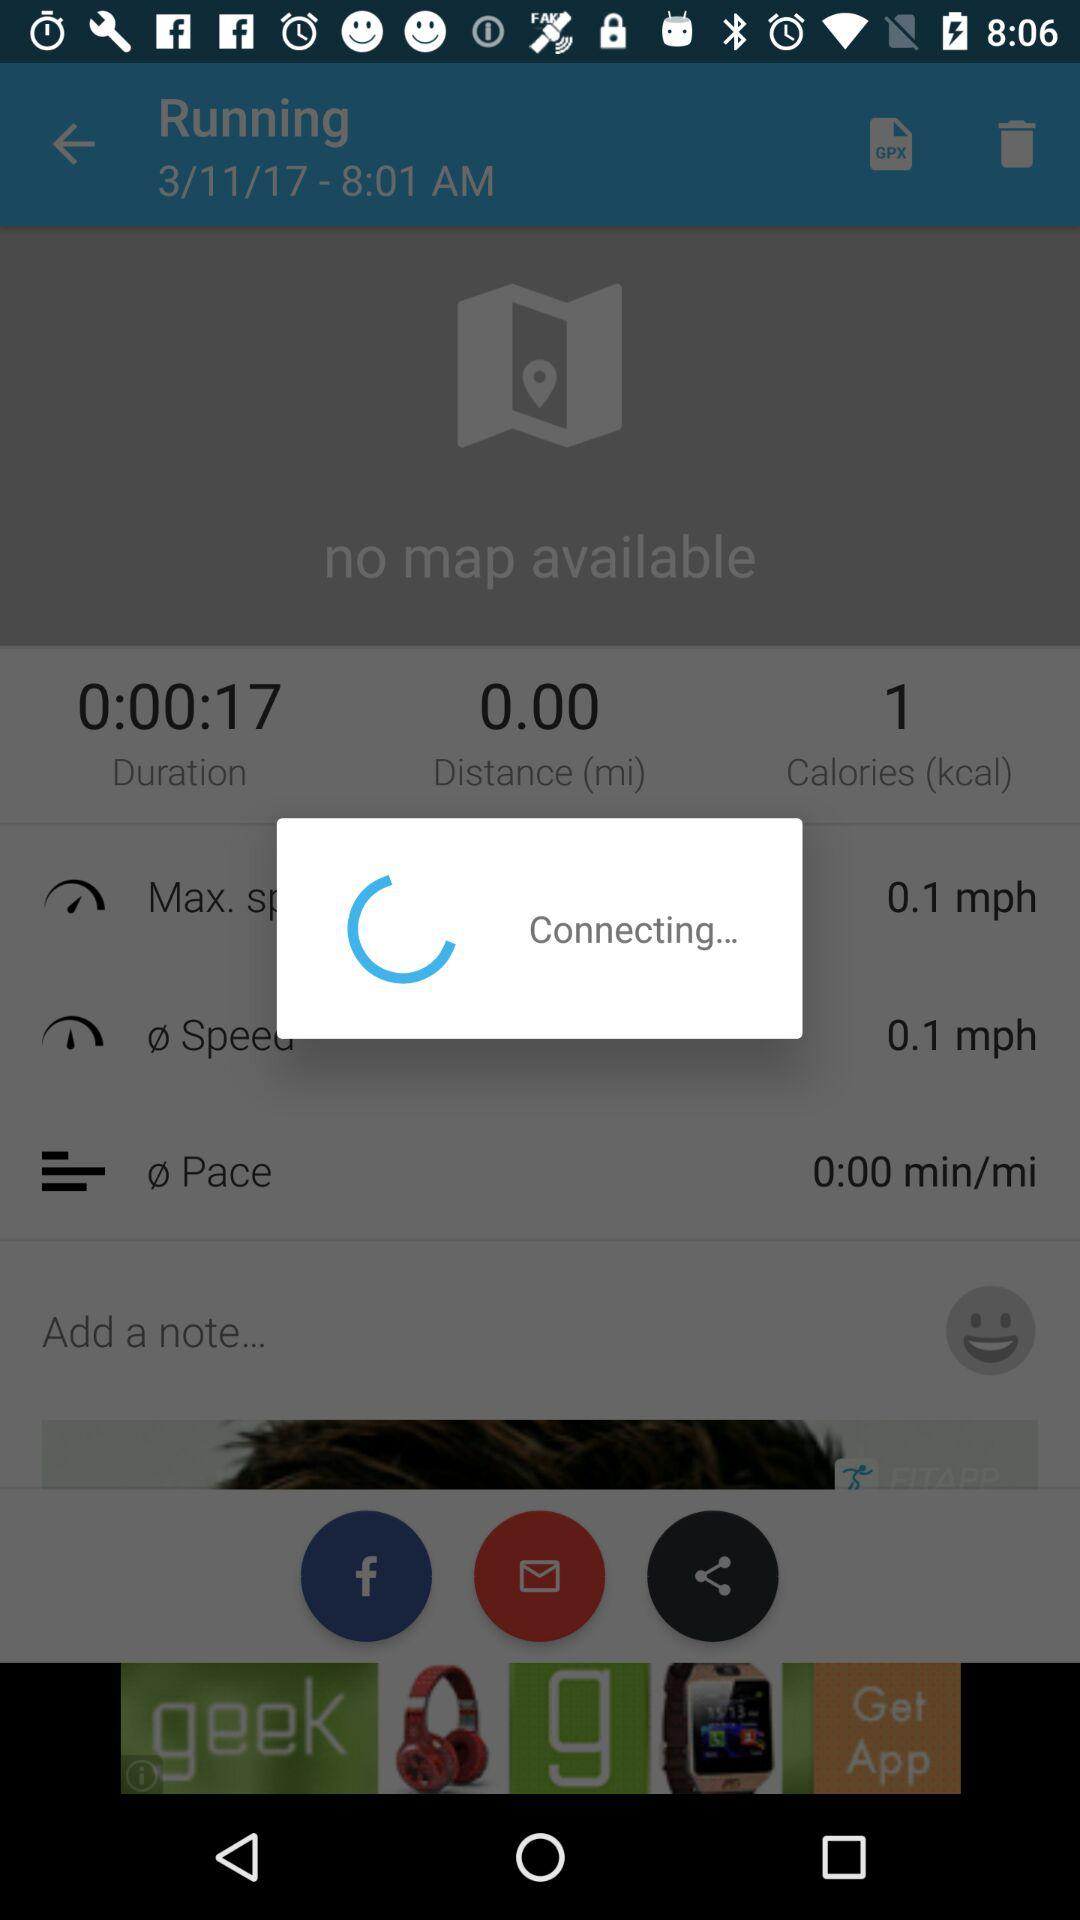What is the running distance?
When the provided information is insufficient, respond with <no answer>. <no answer> 